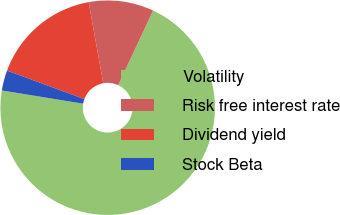Convert chart. <chart><loc_0><loc_0><loc_500><loc_500><pie_chart><fcel>Volatility<fcel>Risk free interest rate<fcel>Dividend yield<fcel>Stock Beta<nl><fcel>70.61%<fcel>9.8%<fcel>16.54%<fcel>3.05%<nl></chart> 